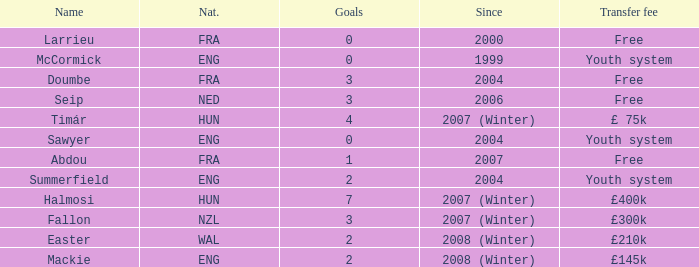What is the average goals Sawyer has? 0.0. Could you parse the entire table? {'header': ['Name', 'Nat.', 'Goals', 'Since', 'Transfer fee'], 'rows': [['Larrieu', 'FRA', '0', '2000', 'Free'], ['McCormick', 'ENG', '0', '1999', 'Youth system'], ['Doumbe', 'FRA', '3', '2004', 'Free'], ['Seip', 'NED', '3', '2006', 'Free'], ['Timár', 'HUN', '4', '2007 (Winter)', '£ 75k'], ['Sawyer', 'ENG', '0', '2004', 'Youth system'], ['Abdou', 'FRA', '1', '2007', 'Free'], ['Summerfield', 'ENG', '2', '2004', 'Youth system'], ['Halmosi', 'HUN', '7', '2007 (Winter)', '£400k'], ['Fallon', 'NZL', '3', '2007 (Winter)', '£300k'], ['Easter', 'WAL', '2', '2008 (Winter)', '£210k'], ['Mackie', 'ENG', '2', '2008 (Winter)', '£145k']]} 